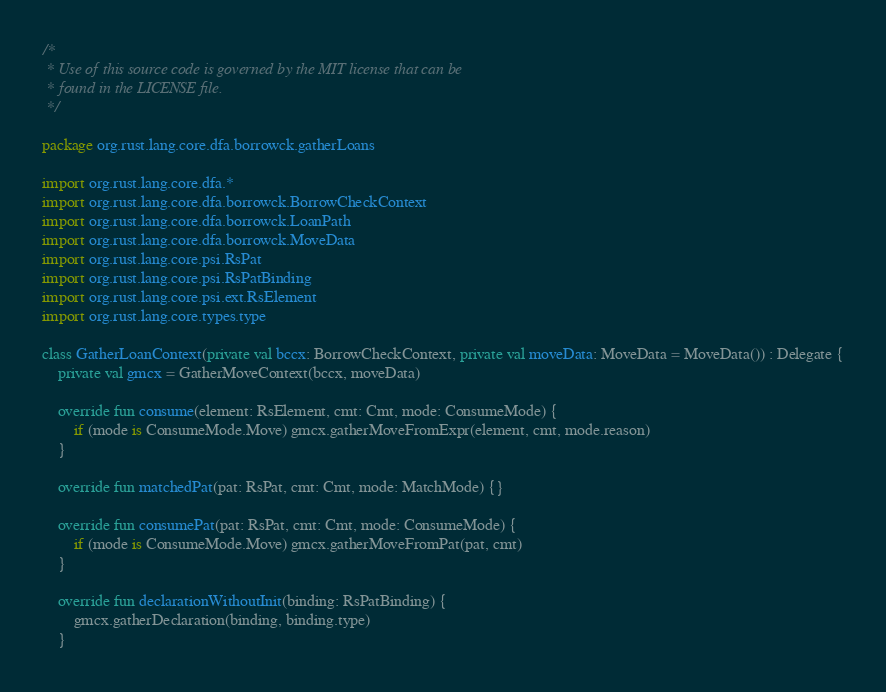<code> <loc_0><loc_0><loc_500><loc_500><_Kotlin_>/*
 * Use of this source code is governed by the MIT license that can be
 * found in the LICENSE file.
 */

package org.rust.lang.core.dfa.borrowck.gatherLoans

import org.rust.lang.core.dfa.*
import org.rust.lang.core.dfa.borrowck.BorrowCheckContext
import org.rust.lang.core.dfa.borrowck.LoanPath
import org.rust.lang.core.dfa.borrowck.MoveData
import org.rust.lang.core.psi.RsPat
import org.rust.lang.core.psi.RsPatBinding
import org.rust.lang.core.psi.ext.RsElement
import org.rust.lang.core.types.type

class GatherLoanContext(private val bccx: BorrowCheckContext, private val moveData: MoveData = MoveData()) : Delegate {
    private val gmcx = GatherMoveContext(bccx, moveData)

    override fun consume(element: RsElement, cmt: Cmt, mode: ConsumeMode) {
        if (mode is ConsumeMode.Move) gmcx.gatherMoveFromExpr(element, cmt, mode.reason)
    }

    override fun matchedPat(pat: RsPat, cmt: Cmt, mode: MatchMode) {}

    override fun consumePat(pat: RsPat, cmt: Cmt, mode: ConsumeMode) {
        if (mode is ConsumeMode.Move) gmcx.gatherMoveFromPat(pat, cmt)
    }

    override fun declarationWithoutInit(binding: RsPatBinding) {
        gmcx.gatherDeclaration(binding, binding.type)
    }
</code> 